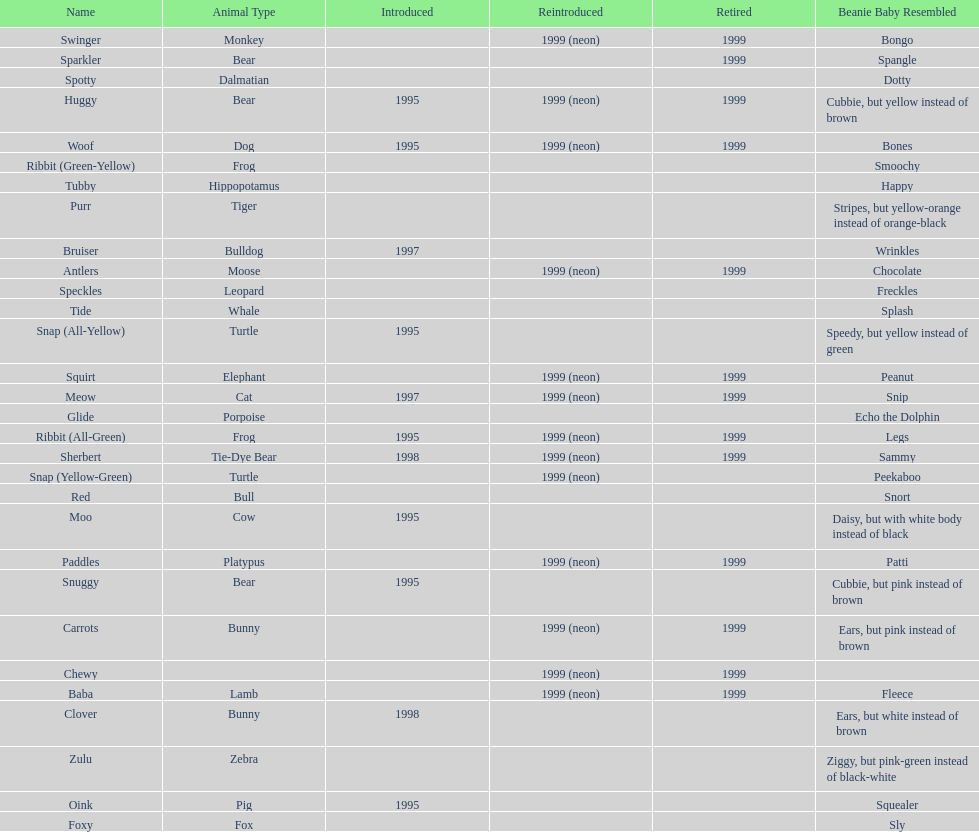How many total pillow pals were both reintroduced and retired in 1999? 12. 